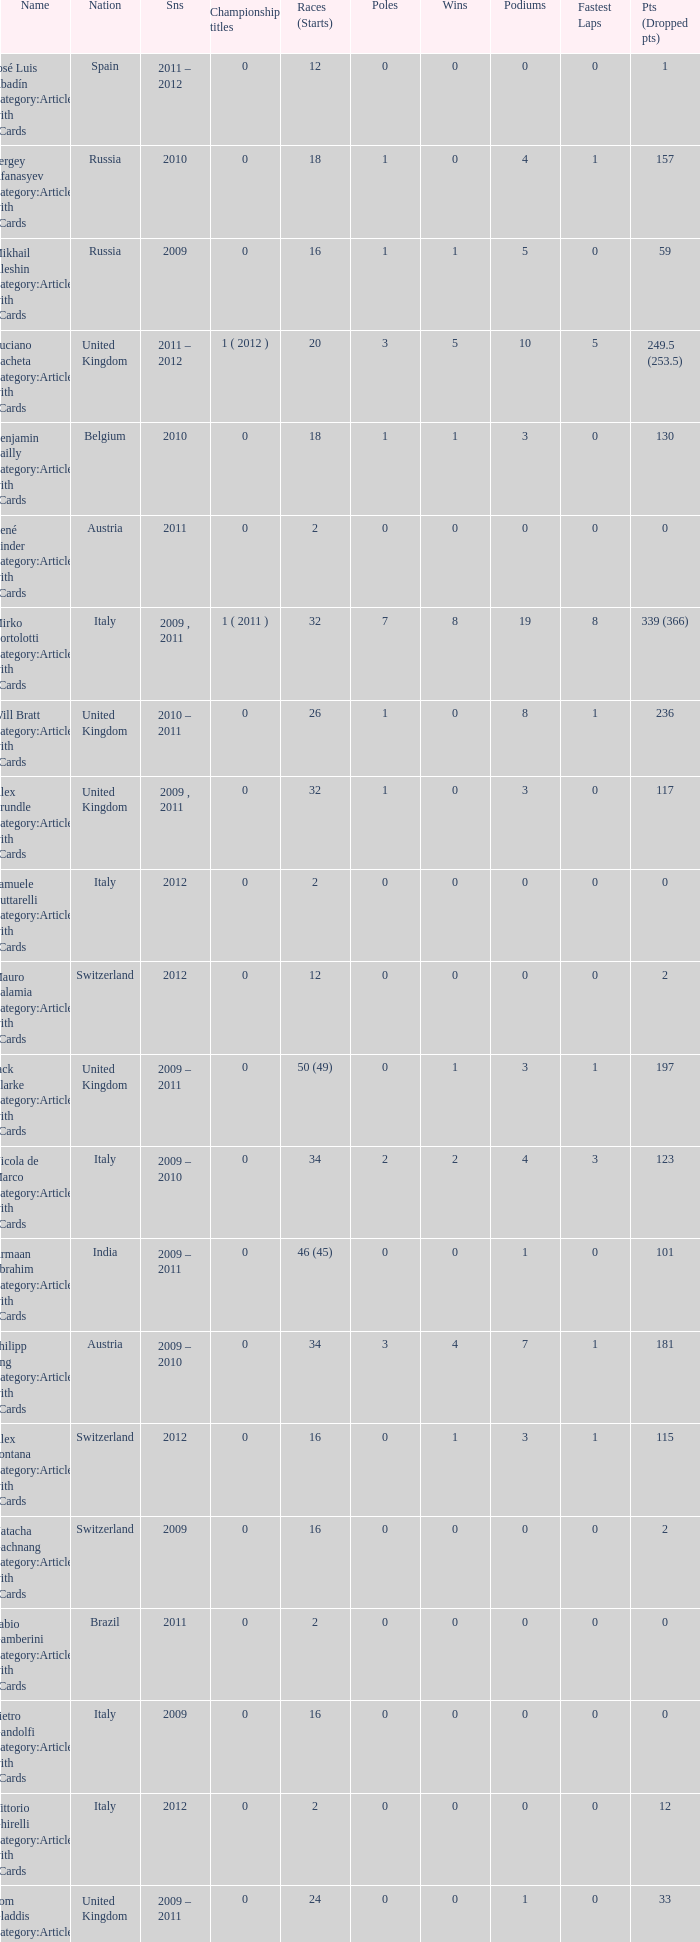What were the beginnings when the points decreased by 18? 8.0. 